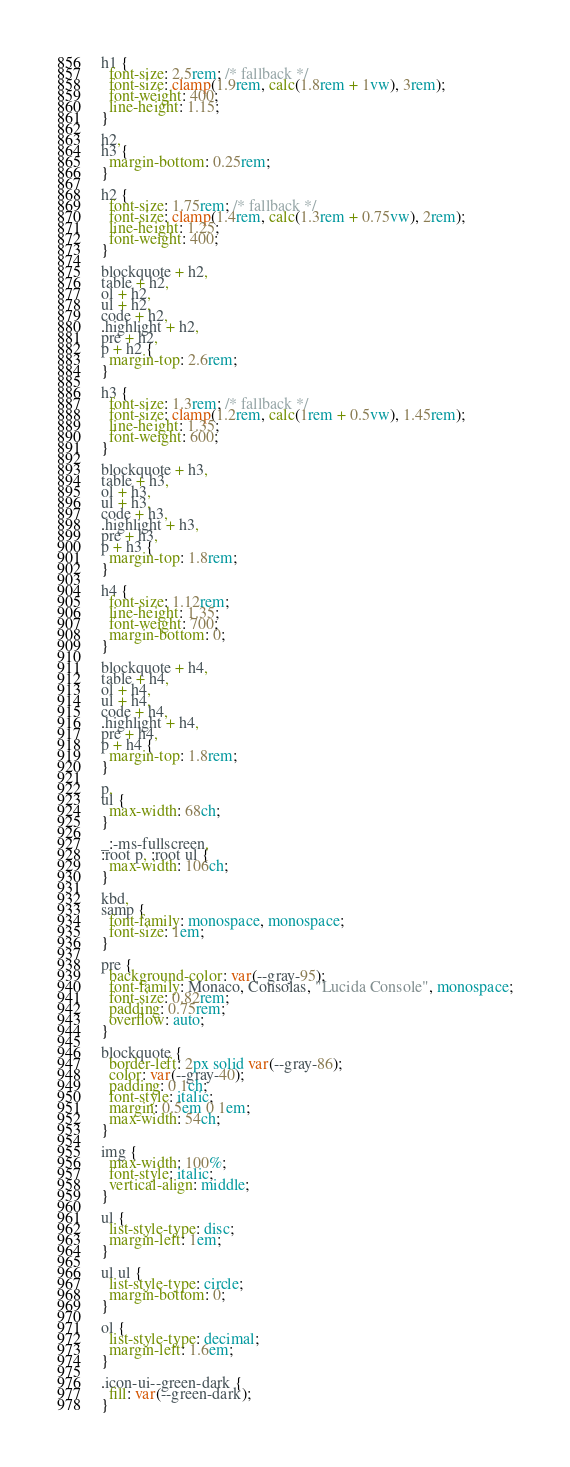Convert code to text. <code><loc_0><loc_0><loc_500><loc_500><_CSS_>h1 {
  font-size: 2.5rem; /* fallback */
  font-size: clamp(1.9rem, calc(1.8rem + 1vw), 3rem);
  font-weight: 400;
  line-height: 1.15;
}

h2,
h3 {
  margin-bottom: 0.25rem;
}

h2 {
  font-size: 1.75rem; /* fallback */
  font-size: clamp(1.4rem, calc(1.3rem + 0.75vw), 2rem);
  line-height: 1.25;
  font-weight: 400;
}

blockquote + h2,
table + h2,
ol + h2,
ul + h2,
code + h2,
.highlight + h2,
pre + h2,
p + h2 {
  margin-top: 2.6rem;
}

h3 {
  font-size: 1.3rem; /* fallback */
  font-size: clamp(1.2rem, calc(1rem + 0.5vw), 1.45rem);
  line-height: 1.35;
  font-weight: 600;
}

blockquote + h3,
table + h3,
ol + h3,
ul + h3,
code + h3,
.highlight + h3,
pre + h3,
p + h3 {
  margin-top: 1.8rem;
}

h4 {
  font-size: 1.12rem;
  line-height: 1.35;
  font-weight: 700;
  margin-bottom: 0;
}

blockquote + h4,
table + h4,
ol + h4,
ul + h4,
code + h4,
.highlight + h4,
pre + h4,
p + h4 {
  margin-top: 1.8rem;
}

p,
ul {
  max-width: 68ch;
}

_:-ms-fullscreen,
:root p, :root ul {
  max-width: 106ch;
}

kbd,
samp {
  font-family: monospace, monospace;
  font-size: 1em;
}

pre {
  background-color: var(--gray-95);
  font-family: Monaco, Consolas, "Lucida Console", monospace;
  font-size: 0.82rem;
  padding: 0.75rem;
  overflow: auto;
}

blockquote {
  border-left: 2px solid var(--gray-86);
  color: var(--gray-40);
  padding: 0 1ch;
  font-style: italic;
  margin: 0.5em 0 1em;
  max-width: 54ch;
}

img {
  max-width: 100%;
  font-style: italic;
  vertical-align: middle;
}

ul {
  list-style-type: disc;
  margin-left: 1em;
}

ul ul {
  list-style-type: circle;
  margin-bottom: 0;
}

ol {
  list-style-type: decimal;
  margin-left: 1.6em;
}

.icon-ui--green-dark {
  fill: var(--green-dark);
}
</code> 